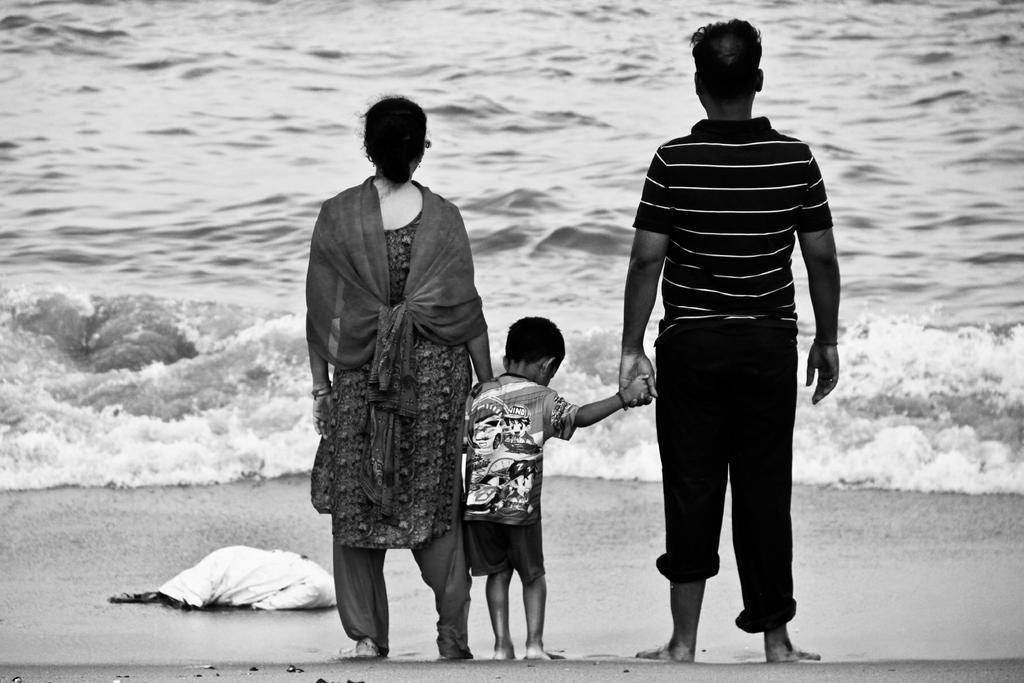Could you give a brief overview of what you see in this image? This image is a black and white image. This image is taken outdoors. At the bottom of the image there is a ground. At the top of the image there is a sea with waves. In the middle of the image a man, a woman and a kid are standing on the ground. 